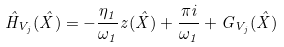<formula> <loc_0><loc_0><loc_500><loc_500>\hat { H } _ { V _ { j } } ( \hat { X } ) = - \frac { \eta _ { 1 } } { \omega _ { 1 } } z ( \hat { X } ) + \frac { \pi i } { \omega _ { 1 } } + G _ { V _ { j } } ( \hat { X } )</formula> 